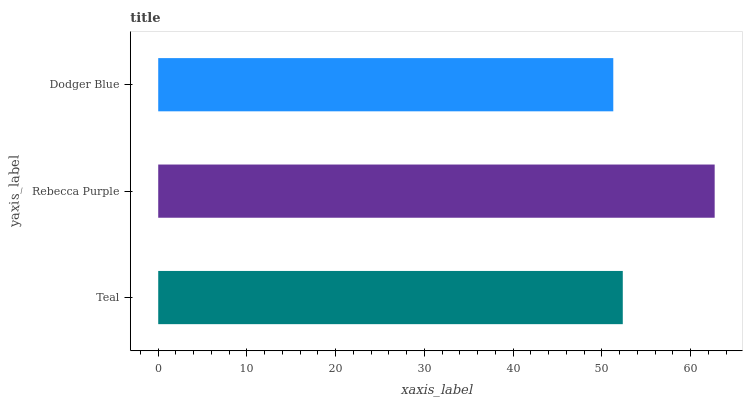Is Dodger Blue the minimum?
Answer yes or no. Yes. Is Rebecca Purple the maximum?
Answer yes or no. Yes. Is Rebecca Purple the minimum?
Answer yes or no. No. Is Dodger Blue the maximum?
Answer yes or no. No. Is Rebecca Purple greater than Dodger Blue?
Answer yes or no. Yes. Is Dodger Blue less than Rebecca Purple?
Answer yes or no. Yes. Is Dodger Blue greater than Rebecca Purple?
Answer yes or no. No. Is Rebecca Purple less than Dodger Blue?
Answer yes or no. No. Is Teal the high median?
Answer yes or no. Yes. Is Teal the low median?
Answer yes or no. Yes. Is Rebecca Purple the high median?
Answer yes or no. No. Is Rebecca Purple the low median?
Answer yes or no. No. 